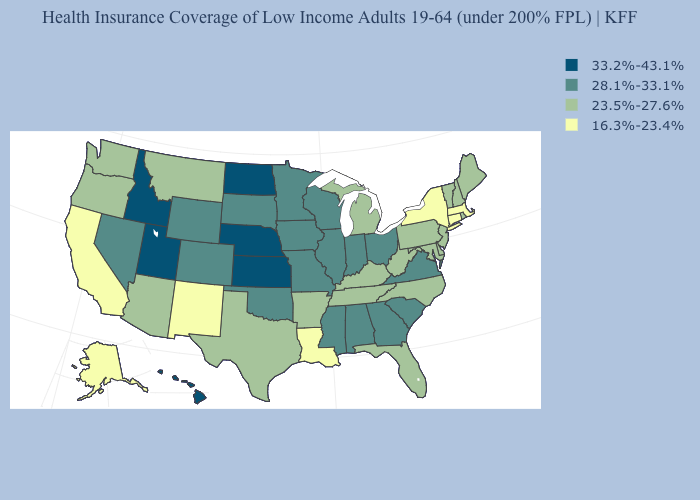What is the value of Nebraska?
Give a very brief answer. 33.2%-43.1%. What is the value of Michigan?
Be succinct. 23.5%-27.6%. Name the states that have a value in the range 23.5%-27.6%?
Concise answer only. Arizona, Arkansas, Delaware, Florida, Kentucky, Maine, Maryland, Michigan, Montana, New Hampshire, New Jersey, North Carolina, Oregon, Pennsylvania, Rhode Island, Tennessee, Texas, Vermont, Washington, West Virginia. Which states have the lowest value in the USA?
Concise answer only. Alaska, California, Connecticut, Louisiana, Massachusetts, New Mexico, New York. Name the states that have a value in the range 16.3%-23.4%?
Short answer required. Alaska, California, Connecticut, Louisiana, Massachusetts, New Mexico, New York. What is the value of Ohio?
Short answer required. 28.1%-33.1%. Does South Carolina have the same value as Vermont?
Short answer required. No. What is the highest value in the USA?
Be succinct. 33.2%-43.1%. What is the value of Alaska?
Concise answer only. 16.3%-23.4%. Name the states that have a value in the range 28.1%-33.1%?
Answer briefly. Alabama, Colorado, Georgia, Illinois, Indiana, Iowa, Minnesota, Mississippi, Missouri, Nevada, Ohio, Oklahoma, South Carolina, South Dakota, Virginia, Wisconsin, Wyoming. Which states have the lowest value in the South?
Short answer required. Louisiana. What is the value of Wyoming?
Concise answer only. 28.1%-33.1%. Does New York have the lowest value in the Northeast?
Short answer required. Yes. What is the highest value in the West ?
Be succinct. 33.2%-43.1%. Which states hav the highest value in the MidWest?
Write a very short answer. Kansas, Nebraska, North Dakota. 